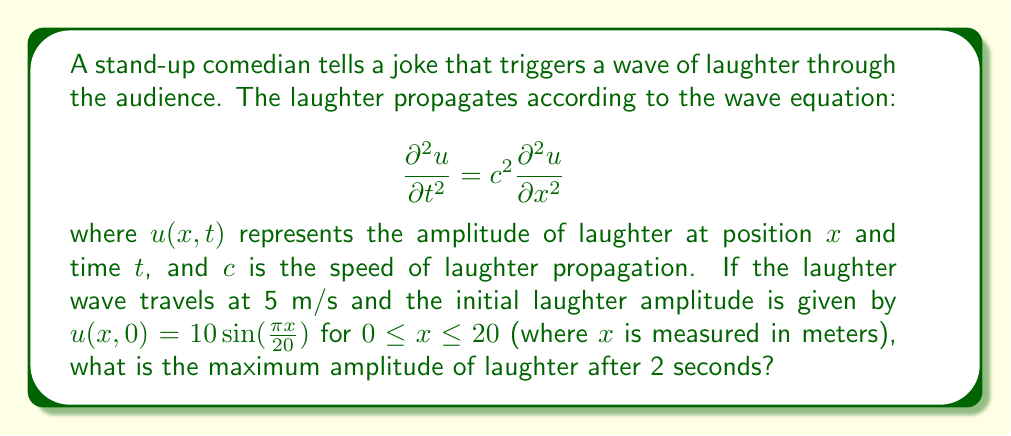Show me your answer to this math problem. Let's approach this step-by-step:

1) The general solution to the wave equation is given by D'Alembert's formula:

   $$u(x,t) = f(x-ct) + g(x+ct)$$

   where $f$ and $g$ are arbitrary functions determined by initial conditions.

2) Given the initial condition $u(x,0) = 10 \sin(\frac{\pi x}{20})$, we can deduce that:

   $$f(x) + g(x) = 10 \sin(\frac{\pi x}{20})$$

3) Assuming the initial velocity is zero (i.e., $\frac{\partial u}{\partial t}(x,0) = 0$), we get:

   $$f'(x) - g'(x) = 0$$

4) Solving these equations leads to:

   $$f(x) = g(x) = 5 \sin(\frac{\pi x}{20})$$

5) Therefore, the solution is:

   $$u(x,t) = 5 \sin(\frac{\pi (x-ct)}{20}) + 5 \sin(\frac{\pi (x+ct)}{20})$$

6) Using the trigonometric identity for the sum of sines, this can be rewritten as:

   $$u(x,t) = 10 \sin(\frac{\pi x}{20}) \cos(\frac{\pi ct}{20})$$

7) The maximum amplitude occurs when $\sin(\frac{\pi x}{20}) = 1$ and $\cos(\frac{\pi ct}{20})$ is at its maximum absolute value of 1.

8) After 2 seconds, with $c = 5$ m/s:

   $$\cos(\frac{\pi ct}{20}) = \cos(\frac{\pi \cdot 5 \cdot 2}{20}) = \cos(\frac{\pi}{2}) = 0$$

9) Therefore, the maximum amplitude after 2 seconds is:

   $$u_{max} = 10 \cdot 1 \cdot 0 = 0$$
Answer: 0 